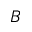Convert formula to latex. <formula><loc_0><loc_0><loc_500><loc_500>B</formula> 